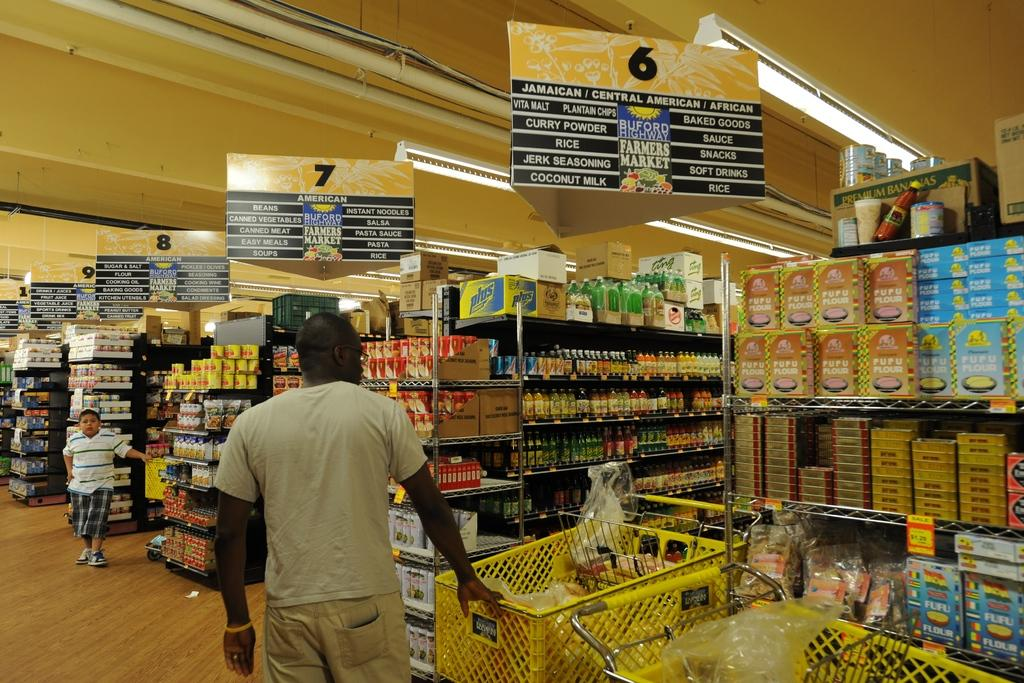<image>
Relay a brief, clear account of the picture shown. A person with a shopping cart is in the front of isle 6. 